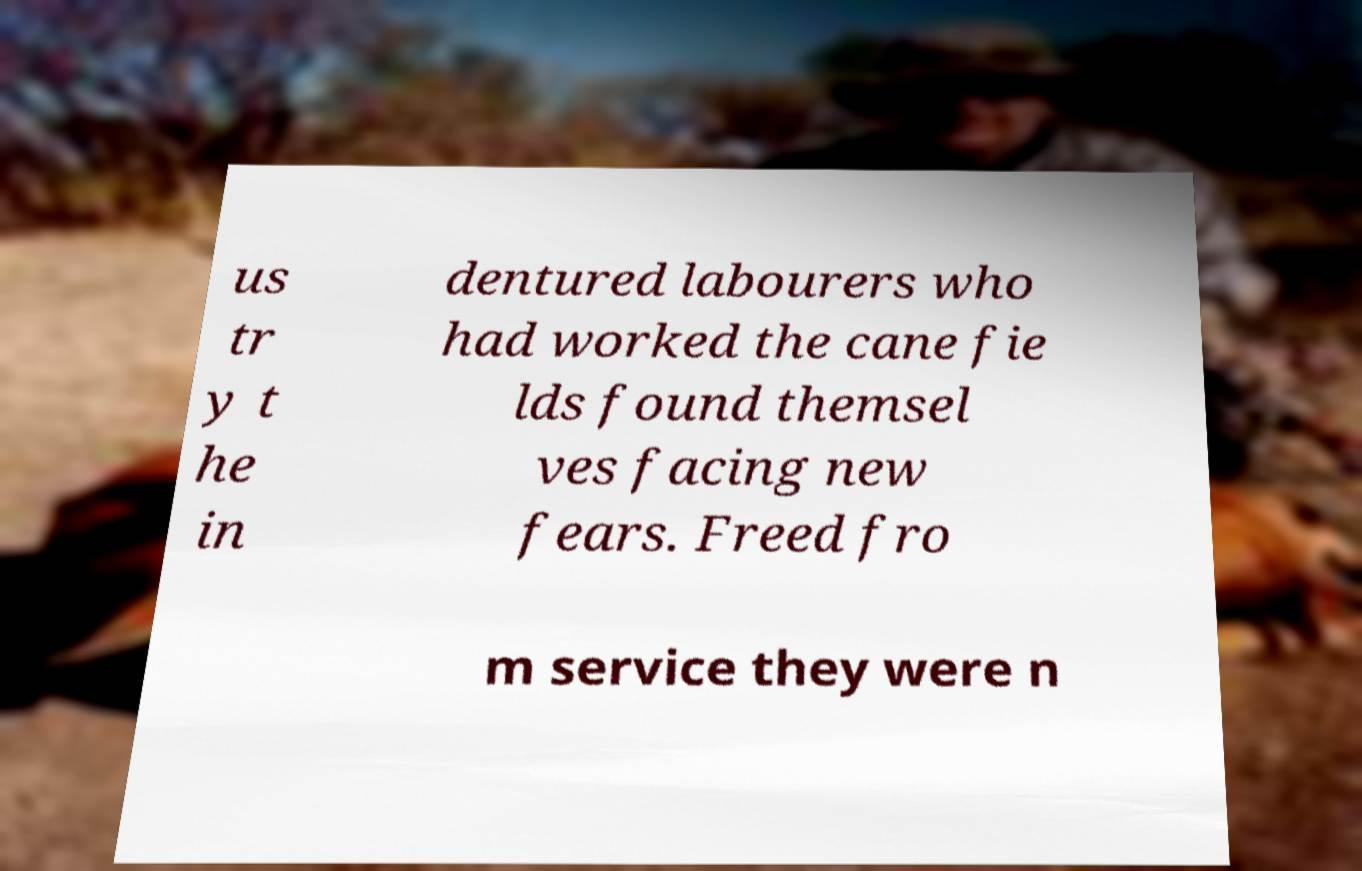Can you accurately transcribe the text from the provided image for me? us tr y t he in dentured labourers who had worked the cane fie lds found themsel ves facing new fears. Freed fro m service they were n 